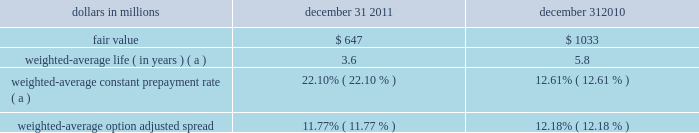Interest-earning assets including unearned income in the accretion of fair value adjustments on discounts recognized on acquired or purchased loans is recognized based on the constant effective yield of the financial instrument .
The timing and amount of revenue that we recognize in any period is dependent on estimates , judgments , assumptions , and interpretation of contractual terms .
Changes in these factors can have a significant impact on revenue recognized in any period due to changes in products , market conditions or industry norms .
Residential and commercial mortgage servicing rights we elect to measure our residential mortgage servicing rights ( msrs ) at fair value .
This election was made to be consistent with our risk management strategy to hedge changes in the fair value of these assets as described below .
The fair value of residential msrs is estimated by using a cash flow valuation model which calculates the present value of estimated future net servicing cash flows , taking into consideration actual and expected mortgage loan prepayment rates , discount rates , servicing costs , and other economic factors which are determined based on current market conditions .
Assumptions incorporated into the residential msrs valuation model reflect management 2019s best estimate of factors that a market participant would use in valuing the residential msrs .
Although sales of residential msrs do occur , residential msrs do not trade in an active market with readily observable prices so the precise terms and conditions of sales are not available .
As a benchmark for the reasonableness of its residential msrs fair value , pnc obtains opinions of value from independent parties ( 201cbrokers 201d ) .
These brokers provided a range ( +/- 10 bps ) based upon their own discounted cash flow calculations of our portfolio that reflected conditions in the secondary market , and any recently executed servicing transactions .
Pnc compares its internally-developed residential msrs value to the ranges of values received from the brokers .
If our residential msrs fair value falls outside of the brokers 2019 ranges , management will assess whether a valuation adjustment is warranted .
For 2011 and 2010 , pnc 2019s residential msrs value has not fallen outside of the brokers 2019 ranges .
We consider our residential msrs value to represent a reasonable estimate of fair value .
Commercial msrs are purchased or originated when loans are sold with servicing retained .
Commercial msrs do not trade in an active market with readily observable prices so the precise terms and conditions of sales are not available .
Commercial msrs are initially recorded at fair value and are subsequently accounted for at the lower of amortized cost or fair value .
Commercial msrs are periodically evaluated for impairment .
For purposes of impairment , the commercial mortgage servicing rights are stratified based on asset type , which characterizes the predominant risk of the underlying financial asset .
The fair value of commercial msrs is estimated by using an internal valuation model .
The model calculates the present value of estimated future net servicing cash flows considering estimates of servicing revenue and costs , discount rates and prepayment speeds .
Pnc employs risk management strategies designed to protect the value of msrs from changes in interest rates and related market factors .
Residential msrs values are economically hedged with securities and derivatives , including interest-rate swaps , options , and forward mortgage-backed and futures contracts .
As interest rates change , these financial instruments are expected to have changes in fair value negatively correlated to the change in fair value of the hedged residential msrs portfolio .
The hedge relationships are actively managed in response to changing market conditions over the life of the residential msrs assets .
Commercial msrs are economically hedged at a macro level or with specific derivatives to protect against a significant decline in interest rates .
Selecting appropriate financial instruments to economically hedge residential or commercial msrs requires significant management judgment to assess how mortgage rates and prepayment speeds could affect the future values of msrs .
Hedging results can frequently be less predictable in the short term , but over longer periods of time are expected to protect the economic value of the msrs .
The fair value of residential and commercial msrs and significant inputs to the valuation model as of december 31 , 2011 are shown in the tables below .
The expected and actual rates of mortgage loan prepayments are significant factors driving the fair value .
Management uses a third-party model to estimate future residential loan prepayments and internal proprietary models to estimate future commercial loan prepayments .
These models have been refined based on current market conditions .
Future interest rates are another important factor in the valuation of msrs .
Management utilizes market implied forward interest rates to estimate the future direction of mortgage and discount rates .
The forward rates utilized are derived from the current yield curve for u.s .
Dollar interest rate swaps and are consistent with pricing of capital markets instruments .
Changes in the shape and slope of the forward curve in future periods may result in volatility in the fair value estimate .
Residential mortgage servicing rights dollars in millions december 31 december 31 .
Weighted-average constant prepayment rate ( a ) 22.10% ( 22.10 % ) 12.61% ( 12.61 % ) weighted-average option adjusted spread 11.77% ( 11.77 % ) 12.18% ( 12.18 % ) ( a ) changes in weighted-average life and weighted-average constant prepayment rate reflect the cumulative impact of changes in rates , prepayment expectations and model changes .
The pnc financial services group , inc .
2013 form 10-k 65 .
What was the change in fair value residential mortgage servicing rights dollars in millions between 2020 and 2011? 
Computations: (1033 - 647)
Answer: 386.0. 